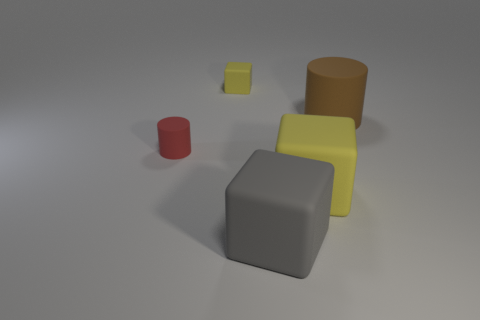Subtract all large gray rubber blocks. How many blocks are left? 2 Subtract all brown cylinders. How many cylinders are left? 1 Subtract 0 yellow cylinders. How many objects are left? 5 Subtract all cylinders. How many objects are left? 3 Subtract 2 blocks. How many blocks are left? 1 Subtract all green cylinders. Subtract all brown blocks. How many cylinders are left? 2 Subtract all yellow balls. How many red cylinders are left? 1 Subtract all large brown cylinders. Subtract all large cubes. How many objects are left? 2 Add 5 large matte objects. How many large matte objects are left? 8 Add 3 tiny yellow balls. How many tiny yellow balls exist? 3 